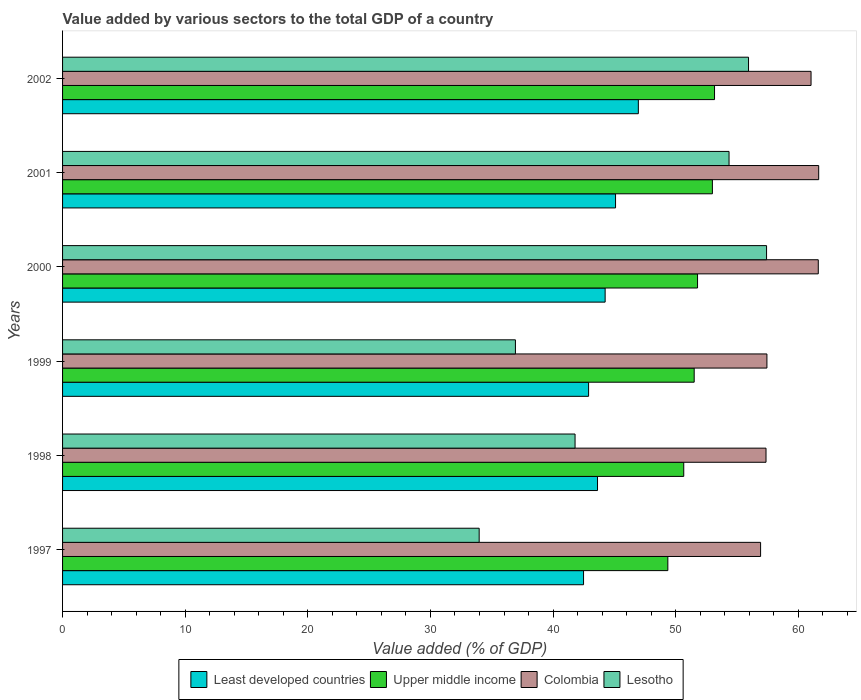How many different coloured bars are there?
Offer a very short reply. 4. Are the number of bars on each tick of the Y-axis equal?
Give a very brief answer. Yes. How many bars are there on the 6th tick from the top?
Give a very brief answer. 4. How many bars are there on the 4th tick from the bottom?
Provide a succinct answer. 4. In how many cases, is the number of bars for a given year not equal to the number of legend labels?
Provide a succinct answer. 0. What is the value added by various sectors to the total GDP in Lesotho in 2002?
Ensure brevity in your answer.  55.94. Across all years, what is the maximum value added by various sectors to the total GDP in Upper middle income?
Provide a short and direct response. 53.17. Across all years, what is the minimum value added by various sectors to the total GDP in Lesotho?
Your answer should be compact. 33.97. In which year was the value added by various sectors to the total GDP in Upper middle income maximum?
Your response must be concise. 2002. In which year was the value added by various sectors to the total GDP in Colombia minimum?
Your response must be concise. 1997. What is the total value added by various sectors to the total GDP in Colombia in the graph?
Ensure brevity in your answer.  356.05. What is the difference between the value added by various sectors to the total GDP in Upper middle income in 2000 and that in 2001?
Keep it short and to the point. -1.21. What is the difference between the value added by various sectors to the total GDP in Least developed countries in 1998 and the value added by various sectors to the total GDP in Upper middle income in 2001?
Your response must be concise. -9.37. What is the average value added by various sectors to the total GDP in Colombia per year?
Your answer should be compact. 59.34. In the year 2002, what is the difference between the value added by various sectors to the total GDP in Upper middle income and value added by various sectors to the total GDP in Least developed countries?
Offer a terse response. 6.21. What is the ratio of the value added by various sectors to the total GDP in Colombia in 1997 to that in 2002?
Your response must be concise. 0.93. Is the value added by various sectors to the total GDP in Colombia in 1998 less than that in 1999?
Ensure brevity in your answer.  Yes. What is the difference between the highest and the second highest value added by various sectors to the total GDP in Least developed countries?
Provide a short and direct response. 1.86. What is the difference between the highest and the lowest value added by various sectors to the total GDP in Colombia?
Your response must be concise. 4.74. Is the sum of the value added by various sectors to the total GDP in Colombia in 1998 and 2001 greater than the maximum value added by various sectors to the total GDP in Upper middle income across all years?
Offer a very short reply. Yes. What does the 1st bar from the top in 2001 represents?
Provide a short and direct response. Lesotho. Is it the case that in every year, the sum of the value added by various sectors to the total GDP in Lesotho and value added by various sectors to the total GDP in Colombia is greater than the value added by various sectors to the total GDP in Least developed countries?
Your answer should be very brief. Yes. Are all the bars in the graph horizontal?
Your answer should be very brief. Yes. What is the difference between two consecutive major ticks on the X-axis?
Keep it short and to the point. 10. Are the values on the major ticks of X-axis written in scientific E-notation?
Your response must be concise. No. Does the graph contain any zero values?
Provide a short and direct response. No. Does the graph contain grids?
Keep it short and to the point. No. Where does the legend appear in the graph?
Provide a short and direct response. Bottom center. How are the legend labels stacked?
Your answer should be very brief. Horizontal. What is the title of the graph?
Offer a terse response. Value added by various sectors to the total GDP of a country. What is the label or title of the X-axis?
Give a very brief answer. Value added (% of GDP). What is the Value added (% of GDP) of Least developed countries in 1997?
Provide a succinct answer. 42.49. What is the Value added (% of GDP) of Upper middle income in 1997?
Provide a short and direct response. 49.36. What is the Value added (% of GDP) in Colombia in 1997?
Give a very brief answer. 56.92. What is the Value added (% of GDP) in Lesotho in 1997?
Give a very brief answer. 33.97. What is the Value added (% of GDP) in Least developed countries in 1998?
Offer a very short reply. 43.62. What is the Value added (% of GDP) in Upper middle income in 1998?
Your response must be concise. 50.66. What is the Value added (% of GDP) in Colombia in 1998?
Make the answer very short. 57.37. What is the Value added (% of GDP) in Lesotho in 1998?
Provide a succinct answer. 41.79. What is the Value added (% of GDP) in Least developed countries in 1999?
Make the answer very short. 42.9. What is the Value added (% of GDP) in Upper middle income in 1999?
Your answer should be compact. 51.51. What is the Value added (% of GDP) of Colombia in 1999?
Your answer should be compact. 57.44. What is the Value added (% of GDP) in Lesotho in 1999?
Your response must be concise. 36.93. What is the Value added (% of GDP) of Least developed countries in 2000?
Make the answer very short. 44.25. What is the Value added (% of GDP) of Upper middle income in 2000?
Ensure brevity in your answer.  51.78. What is the Value added (% of GDP) in Colombia in 2000?
Offer a very short reply. 61.63. What is the Value added (% of GDP) in Lesotho in 2000?
Your answer should be compact. 57.41. What is the Value added (% of GDP) of Least developed countries in 2001?
Your response must be concise. 45.1. What is the Value added (% of GDP) in Upper middle income in 2001?
Offer a very short reply. 52.99. What is the Value added (% of GDP) of Colombia in 2001?
Offer a very short reply. 61.66. What is the Value added (% of GDP) in Lesotho in 2001?
Offer a terse response. 54.35. What is the Value added (% of GDP) in Least developed countries in 2002?
Make the answer very short. 46.95. What is the Value added (% of GDP) in Upper middle income in 2002?
Give a very brief answer. 53.17. What is the Value added (% of GDP) of Colombia in 2002?
Offer a very short reply. 61.04. What is the Value added (% of GDP) in Lesotho in 2002?
Provide a succinct answer. 55.94. Across all years, what is the maximum Value added (% of GDP) of Least developed countries?
Make the answer very short. 46.95. Across all years, what is the maximum Value added (% of GDP) of Upper middle income?
Give a very brief answer. 53.17. Across all years, what is the maximum Value added (% of GDP) of Colombia?
Your answer should be very brief. 61.66. Across all years, what is the maximum Value added (% of GDP) in Lesotho?
Give a very brief answer. 57.41. Across all years, what is the minimum Value added (% of GDP) in Least developed countries?
Provide a succinct answer. 42.49. Across all years, what is the minimum Value added (% of GDP) in Upper middle income?
Offer a very short reply. 49.36. Across all years, what is the minimum Value added (% of GDP) of Colombia?
Ensure brevity in your answer.  56.92. Across all years, what is the minimum Value added (% of GDP) in Lesotho?
Offer a very short reply. 33.97. What is the total Value added (% of GDP) of Least developed countries in the graph?
Your response must be concise. 265.3. What is the total Value added (% of GDP) in Upper middle income in the graph?
Keep it short and to the point. 309.47. What is the total Value added (% of GDP) in Colombia in the graph?
Offer a terse response. 356.05. What is the total Value added (% of GDP) of Lesotho in the graph?
Ensure brevity in your answer.  280.4. What is the difference between the Value added (% of GDP) in Least developed countries in 1997 and that in 1998?
Offer a terse response. -1.14. What is the difference between the Value added (% of GDP) of Upper middle income in 1997 and that in 1998?
Offer a very short reply. -1.3. What is the difference between the Value added (% of GDP) in Colombia in 1997 and that in 1998?
Offer a terse response. -0.44. What is the difference between the Value added (% of GDP) of Lesotho in 1997 and that in 1998?
Keep it short and to the point. -7.82. What is the difference between the Value added (% of GDP) of Least developed countries in 1997 and that in 1999?
Your response must be concise. -0.41. What is the difference between the Value added (% of GDP) of Upper middle income in 1997 and that in 1999?
Provide a succinct answer. -2.15. What is the difference between the Value added (% of GDP) in Colombia in 1997 and that in 1999?
Make the answer very short. -0.52. What is the difference between the Value added (% of GDP) in Lesotho in 1997 and that in 1999?
Ensure brevity in your answer.  -2.96. What is the difference between the Value added (% of GDP) of Least developed countries in 1997 and that in 2000?
Your response must be concise. -1.76. What is the difference between the Value added (% of GDP) in Upper middle income in 1997 and that in 2000?
Offer a very short reply. -2.42. What is the difference between the Value added (% of GDP) of Colombia in 1997 and that in 2000?
Your response must be concise. -4.7. What is the difference between the Value added (% of GDP) of Lesotho in 1997 and that in 2000?
Give a very brief answer. -23.44. What is the difference between the Value added (% of GDP) of Least developed countries in 1997 and that in 2001?
Your response must be concise. -2.61. What is the difference between the Value added (% of GDP) in Upper middle income in 1997 and that in 2001?
Give a very brief answer. -3.63. What is the difference between the Value added (% of GDP) in Colombia in 1997 and that in 2001?
Offer a very short reply. -4.74. What is the difference between the Value added (% of GDP) of Lesotho in 1997 and that in 2001?
Keep it short and to the point. -20.38. What is the difference between the Value added (% of GDP) of Least developed countries in 1997 and that in 2002?
Offer a terse response. -4.47. What is the difference between the Value added (% of GDP) in Upper middle income in 1997 and that in 2002?
Your answer should be compact. -3.81. What is the difference between the Value added (% of GDP) in Colombia in 1997 and that in 2002?
Offer a very short reply. -4.11. What is the difference between the Value added (% of GDP) in Lesotho in 1997 and that in 2002?
Your answer should be very brief. -21.97. What is the difference between the Value added (% of GDP) of Least developed countries in 1998 and that in 1999?
Keep it short and to the point. 0.73. What is the difference between the Value added (% of GDP) of Upper middle income in 1998 and that in 1999?
Provide a short and direct response. -0.85. What is the difference between the Value added (% of GDP) of Colombia in 1998 and that in 1999?
Offer a terse response. -0.07. What is the difference between the Value added (% of GDP) of Lesotho in 1998 and that in 1999?
Keep it short and to the point. 4.86. What is the difference between the Value added (% of GDP) of Least developed countries in 1998 and that in 2000?
Your answer should be very brief. -0.62. What is the difference between the Value added (% of GDP) in Upper middle income in 1998 and that in 2000?
Provide a short and direct response. -1.13. What is the difference between the Value added (% of GDP) of Colombia in 1998 and that in 2000?
Your answer should be compact. -4.26. What is the difference between the Value added (% of GDP) of Lesotho in 1998 and that in 2000?
Provide a succinct answer. -15.62. What is the difference between the Value added (% of GDP) of Least developed countries in 1998 and that in 2001?
Your answer should be compact. -1.47. What is the difference between the Value added (% of GDP) of Upper middle income in 1998 and that in 2001?
Provide a short and direct response. -2.34. What is the difference between the Value added (% of GDP) of Colombia in 1998 and that in 2001?
Your answer should be compact. -4.3. What is the difference between the Value added (% of GDP) in Lesotho in 1998 and that in 2001?
Ensure brevity in your answer.  -12.56. What is the difference between the Value added (% of GDP) in Least developed countries in 1998 and that in 2002?
Your response must be concise. -3.33. What is the difference between the Value added (% of GDP) of Upper middle income in 1998 and that in 2002?
Make the answer very short. -2.51. What is the difference between the Value added (% of GDP) of Colombia in 1998 and that in 2002?
Give a very brief answer. -3.67. What is the difference between the Value added (% of GDP) of Lesotho in 1998 and that in 2002?
Keep it short and to the point. -14.15. What is the difference between the Value added (% of GDP) of Least developed countries in 1999 and that in 2000?
Make the answer very short. -1.35. What is the difference between the Value added (% of GDP) of Upper middle income in 1999 and that in 2000?
Offer a terse response. -0.27. What is the difference between the Value added (% of GDP) of Colombia in 1999 and that in 2000?
Your answer should be compact. -4.19. What is the difference between the Value added (% of GDP) of Lesotho in 1999 and that in 2000?
Make the answer very short. -20.48. What is the difference between the Value added (% of GDP) in Least developed countries in 1999 and that in 2001?
Keep it short and to the point. -2.2. What is the difference between the Value added (% of GDP) of Upper middle income in 1999 and that in 2001?
Provide a short and direct response. -1.48. What is the difference between the Value added (% of GDP) in Colombia in 1999 and that in 2001?
Keep it short and to the point. -4.22. What is the difference between the Value added (% of GDP) of Lesotho in 1999 and that in 2001?
Provide a succinct answer. -17.42. What is the difference between the Value added (% of GDP) of Least developed countries in 1999 and that in 2002?
Keep it short and to the point. -4.06. What is the difference between the Value added (% of GDP) in Upper middle income in 1999 and that in 2002?
Provide a short and direct response. -1.66. What is the difference between the Value added (% of GDP) in Colombia in 1999 and that in 2002?
Your answer should be very brief. -3.6. What is the difference between the Value added (% of GDP) of Lesotho in 1999 and that in 2002?
Your answer should be compact. -19.01. What is the difference between the Value added (% of GDP) of Least developed countries in 2000 and that in 2001?
Make the answer very short. -0.85. What is the difference between the Value added (% of GDP) in Upper middle income in 2000 and that in 2001?
Make the answer very short. -1.21. What is the difference between the Value added (% of GDP) in Colombia in 2000 and that in 2001?
Keep it short and to the point. -0.03. What is the difference between the Value added (% of GDP) in Lesotho in 2000 and that in 2001?
Offer a terse response. 3.06. What is the difference between the Value added (% of GDP) in Least developed countries in 2000 and that in 2002?
Give a very brief answer. -2.71. What is the difference between the Value added (% of GDP) in Upper middle income in 2000 and that in 2002?
Your response must be concise. -1.39. What is the difference between the Value added (% of GDP) in Colombia in 2000 and that in 2002?
Offer a terse response. 0.59. What is the difference between the Value added (% of GDP) in Lesotho in 2000 and that in 2002?
Ensure brevity in your answer.  1.47. What is the difference between the Value added (% of GDP) in Least developed countries in 2001 and that in 2002?
Ensure brevity in your answer.  -1.86. What is the difference between the Value added (% of GDP) in Upper middle income in 2001 and that in 2002?
Make the answer very short. -0.17. What is the difference between the Value added (% of GDP) in Colombia in 2001 and that in 2002?
Make the answer very short. 0.62. What is the difference between the Value added (% of GDP) in Lesotho in 2001 and that in 2002?
Your response must be concise. -1.59. What is the difference between the Value added (% of GDP) of Least developed countries in 1997 and the Value added (% of GDP) of Upper middle income in 1998?
Your answer should be very brief. -8.17. What is the difference between the Value added (% of GDP) in Least developed countries in 1997 and the Value added (% of GDP) in Colombia in 1998?
Offer a terse response. -14.88. What is the difference between the Value added (% of GDP) in Least developed countries in 1997 and the Value added (% of GDP) in Lesotho in 1998?
Your answer should be compact. 0.69. What is the difference between the Value added (% of GDP) in Upper middle income in 1997 and the Value added (% of GDP) in Colombia in 1998?
Offer a very short reply. -8.01. What is the difference between the Value added (% of GDP) in Upper middle income in 1997 and the Value added (% of GDP) in Lesotho in 1998?
Offer a terse response. 7.57. What is the difference between the Value added (% of GDP) of Colombia in 1997 and the Value added (% of GDP) of Lesotho in 1998?
Make the answer very short. 15.13. What is the difference between the Value added (% of GDP) in Least developed countries in 1997 and the Value added (% of GDP) in Upper middle income in 1999?
Your answer should be compact. -9.02. What is the difference between the Value added (% of GDP) in Least developed countries in 1997 and the Value added (% of GDP) in Colombia in 1999?
Your answer should be compact. -14.95. What is the difference between the Value added (% of GDP) of Least developed countries in 1997 and the Value added (% of GDP) of Lesotho in 1999?
Your response must be concise. 5.56. What is the difference between the Value added (% of GDP) in Upper middle income in 1997 and the Value added (% of GDP) in Colombia in 1999?
Your answer should be very brief. -8.08. What is the difference between the Value added (% of GDP) in Upper middle income in 1997 and the Value added (% of GDP) in Lesotho in 1999?
Make the answer very short. 12.43. What is the difference between the Value added (% of GDP) of Colombia in 1997 and the Value added (% of GDP) of Lesotho in 1999?
Provide a succinct answer. 19.99. What is the difference between the Value added (% of GDP) in Least developed countries in 1997 and the Value added (% of GDP) in Upper middle income in 2000?
Offer a very short reply. -9.3. What is the difference between the Value added (% of GDP) of Least developed countries in 1997 and the Value added (% of GDP) of Colombia in 2000?
Your answer should be very brief. -19.14. What is the difference between the Value added (% of GDP) in Least developed countries in 1997 and the Value added (% of GDP) in Lesotho in 2000?
Offer a very short reply. -14.93. What is the difference between the Value added (% of GDP) of Upper middle income in 1997 and the Value added (% of GDP) of Colombia in 2000?
Provide a short and direct response. -12.27. What is the difference between the Value added (% of GDP) of Upper middle income in 1997 and the Value added (% of GDP) of Lesotho in 2000?
Your answer should be very brief. -8.05. What is the difference between the Value added (% of GDP) of Colombia in 1997 and the Value added (% of GDP) of Lesotho in 2000?
Offer a very short reply. -0.49. What is the difference between the Value added (% of GDP) of Least developed countries in 1997 and the Value added (% of GDP) of Upper middle income in 2001?
Keep it short and to the point. -10.51. What is the difference between the Value added (% of GDP) in Least developed countries in 1997 and the Value added (% of GDP) in Colombia in 2001?
Your answer should be very brief. -19.18. What is the difference between the Value added (% of GDP) in Least developed countries in 1997 and the Value added (% of GDP) in Lesotho in 2001?
Ensure brevity in your answer.  -11.86. What is the difference between the Value added (% of GDP) in Upper middle income in 1997 and the Value added (% of GDP) in Colombia in 2001?
Your answer should be compact. -12.3. What is the difference between the Value added (% of GDP) in Upper middle income in 1997 and the Value added (% of GDP) in Lesotho in 2001?
Make the answer very short. -4.99. What is the difference between the Value added (% of GDP) of Colombia in 1997 and the Value added (% of GDP) of Lesotho in 2001?
Offer a very short reply. 2.57. What is the difference between the Value added (% of GDP) in Least developed countries in 1997 and the Value added (% of GDP) in Upper middle income in 2002?
Your answer should be very brief. -10.68. What is the difference between the Value added (% of GDP) in Least developed countries in 1997 and the Value added (% of GDP) in Colombia in 2002?
Make the answer very short. -18.55. What is the difference between the Value added (% of GDP) in Least developed countries in 1997 and the Value added (% of GDP) in Lesotho in 2002?
Your answer should be compact. -13.45. What is the difference between the Value added (% of GDP) in Upper middle income in 1997 and the Value added (% of GDP) in Colombia in 2002?
Your response must be concise. -11.68. What is the difference between the Value added (% of GDP) of Upper middle income in 1997 and the Value added (% of GDP) of Lesotho in 2002?
Offer a very short reply. -6.58. What is the difference between the Value added (% of GDP) of Colombia in 1997 and the Value added (% of GDP) of Lesotho in 2002?
Give a very brief answer. 0.98. What is the difference between the Value added (% of GDP) of Least developed countries in 1998 and the Value added (% of GDP) of Upper middle income in 1999?
Your response must be concise. -7.88. What is the difference between the Value added (% of GDP) of Least developed countries in 1998 and the Value added (% of GDP) of Colombia in 1999?
Your answer should be very brief. -13.82. What is the difference between the Value added (% of GDP) of Least developed countries in 1998 and the Value added (% of GDP) of Lesotho in 1999?
Keep it short and to the point. 6.69. What is the difference between the Value added (% of GDP) in Upper middle income in 1998 and the Value added (% of GDP) in Colombia in 1999?
Offer a very short reply. -6.78. What is the difference between the Value added (% of GDP) in Upper middle income in 1998 and the Value added (% of GDP) in Lesotho in 1999?
Keep it short and to the point. 13.73. What is the difference between the Value added (% of GDP) of Colombia in 1998 and the Value added (% of GDP) of Lesotho in 1999?
Offer a terse response. 20.44. What is the difference between the Value added (% of GDP) in Least developed countries in 1998 and the Value added (% of GDP) in Upper middle income in 2000?
Offer a very short reply. -8.16. What is the difference between the Value added (% of GDP) of Least developed countries in 1998 and the Value added (% of GDP) of Colombia in 2000?
Provide a succinct answer. -18. What is the difference between the Value added (% of GDP) in Least developed countries in 1998 and the Value added (% of GDP) in Lesotho in 2000?
Your answer should be very brief. -13.79. What is the difference between the Value added (% of GDP) in Upper middle income in 1998 and the Value added (% of GDP) in Colombia in 2000?
Make the answer very short. -10.97. What is the difference between the Value added (% of GDP) in Upper middle income in 1998 and the Value added (% of GDP) in Lesotho in 2000?
Offer a terse response. -6.75. What is the difference between the Value added (% of GDP) of Colombia in 1998 and the Value added (% of GDP) of Lesotho in 2000?
Keep it short and to the point. -0.04. What is the difference between the Value added (% of GDP) in Least developed countries in 1998 and the Value added (% of GDP) in Upper middle income in 2001?
Provide a short and direct response. -9.37. What is the difference between the Value added (% of GDP) of Least developed countries in 1998 and the Value added (% of GDP) of Colombia in 2001?
Offer a very short reply. -18.04. What is the difference between the Value added (% of GDP) in Least developed countries in 1998 and the Value added (% of GDP) in Lesotho in 2001?
Offer a very short reply. -10.73. What is the difference between the Value added (% of GDP) of Upper middle income in 1998 and the Value added (% of GDP) of Colombia in 2001?
Your answer should be compact. -11. What is the difference between the Value added (% of GDP) in Upper middle income in 1998 and the Value added (% of GDP) in Lesotho in 2001?
Provide a succinct answer. -3.69. What is the difference between the Value added (% of GDP) in Colombia in 1998 and the Value added (% of GDP) in Lesotho in 2001?
Your response must be concise. 3.02. What is the difference between the Value added (% of GDP) in Least developed countries in 1998 and the Value added (% of GDP) in Upper middle income in 2002?
Your answer should be compact. -9.54. What is the difference between the Value added (% of GDP) of Least developed countries in 1998 and the Value added (% of GDP) of Colombia in 2002?
Give a very brief answer. -17.41. What is the difference between the Value added (% of GDP) in Least developed countries in 1998 and the Value added (% of GDP) in Lesotho in 2002?
Your response must be concise. -12.32. What is the difference between the Value added (% of GDP) of Upper middle income in 1998 and the Value added (% of GDP) of Colombia in 2002?
Provide a succinct answer. -10.38. What is the difference between the Value added (% of GDP) of Upper middle income in 1998 and the Value added (% of GDP) of Lesotho in 2002?
Keep it short and to the point. -5.28. What is the difference between the Value added (% of GDP) of Colombia in 1998 and the Value added (% of GDP) of Lesotho in 2002?
Your response must be concise. 1.43. What is the difference between the Value added (% of GDP) in Least developed countries in 1999 and the Value added (% of GDP) in Upper middle income in 2000?
Provide a succinct answer. -8.89. What is the difference between the Value added (% of GDP) in Least developed countries in 1999 and the Value added (% of GDP) in Colombia in 2000?
Your answer should be compact. -18.73. What is the difference between the Value added (% of GDP) of Least developed countries in 1999 and the Value added (% of GDP) of Lesotho in 2000?
Make the answer very short. -14.51. What is the difference between the Value added (% of GDP) of Upper middle income in 1999 and the Value added (% of GDP) of Colombia in 2000?
Give a very brief answer. -10.12. What is the difference between the Value added (% of GDP) in Upper middle income in 1999 and the Value added (% of GDP) in Lesotho in 2000?
Your answer should be very brief. -5.9. What is the difference between the Value added (% of GDP) in Colombia in 1999 and the Value added (% of GDP) in Lesotho in 2000?
Keep it short and to the point. 0.03. What is the difference between the Value added (% of GDP) of Least developed countries in 1999 and the Value added (% of GDP) of Upper middle income in 2001?
Provide a succinct answer. -10.1. What is the difference between the Value added (% of GDP) in Least developed countries in 1999 and the Value added (% of GDP) in Colombia in 2001?
Offer a terse response. -18.76. What is the difference between the Value added (% of GDP) in Least developed countries in 1999 and the Value added (% of GDP) in Lesotho in 2001?
Provide a succinct answer. -11.45. What is the difference between the Value added (% of GDP) in Upper middle income in 1999 and the Value added (% of GDP) in Colombia in 2001?
Provide a short and direct response. -10.15. What is the difference between the Value added (% of GDP) of Upper middle income in 1999 and the Value added (% of GDP) of Lesotho in 2001?
Your answer should be compact. -2.84. What is the difference between the Value added (% of GDP) in Colombia in 1999 and the Value added (% of GDP) in Lesotho in 2001?
Ensure brevity in your answer.  3.09. What is the difference between the Value added (% of GDP) in Least developed countries in 1999 and the Value added (% of GDP) in Upper middle income in 2002?
Give a very brief answer. -10.27. What is the difference between the Value added (% of GDP) of Least developed countries in 1999 and the Value added (% of GDP) of Colombia in 2002?
Provide a short and direct response. -18.14. What is the difference between the Value added (% of GDP) of Least developed countries in 1999 and the Value added (% of GDP) of Lesotho in 2002?
Your response must be concise. -13.04. What is the difference between the Value added (% of GDP) of Upper middle income in 1999 and the Value added (% of GDP) of Colombia in 2002?
Ensure brevity in your answer.  -9.53. What is the difference between the Value added (% of GDP) of Upper middle income in 1999 and the Value added (% of GDP) of Lesotho in 2002?
Offer a very short reply. -4.43. What is the difference between the Value added (% of GDP) of Colombia in 1999 and the Value added (% of GDP) of Lesotho in 2002?
Give a very brief answer. 1.5. What is the difference between the Value added (% of GDP) of Least developed countries in 2000 and the Value added (% of GDP) of Upper middle income in 2001?
Provide a short and direct response. -8.75. What is the difference between the Value added (% of GDP) in Least developed countries in 2000 and the Value added (% of GDP) in Colombia in 2001?
Offer a very short reply. -17.41. What is the difference between the Value added (% of GDP) in Least developed countries in 2000 and the Value added (% of GDP) in Lesotho in 2001?
Make the answer very short. -10.1. What is the difference between the Value added (% of GDP) in Upper middle income in 2000 and the Value added (% of GDP) in Colombia in 2001?
Provide a short and direct response. -9.88. What is the difference between the Value added (% of GDP) of Upper middle income in 2000 and the Value added (% of GDP) of Lesotho in 2001?
Your answer should be very brief. -2.57. What is the difference between the Value added (% of GDP) of Colombia in 2000 and the Value added (% of GDP) of Lesotho in 2001?
Give a very brief answer. 7.28. What is the difference between the Value added (% of GDP) in Least developed countries in 2000 and the Value added (% of GDP) in Upper middle income in 2002?
Your response must be concise. -8.92. What is the difference between the Value added (% of GDP) in Least developed countries in 2000 and the Value added (% of GDP) in Colombia in 2002?
Offer a very short reply. -16.79. What is the difference between the Value added (% of GDP) of Least developed countries in 2000 and the Value added (% of GDP) of Lesotho in 2002?
Provide a succinct answer. -11.69. What is the difference between the Value added (% of GDP) of Upper middle income in 2000 and the Value added (% of GDP) of Colombia in 2002?
Ensure brevity in your answer.  -9.26. What is the difference between the Value added (% of GDP) in Upper middle income in 2000 and the Value added (% of GDP) in Lesotho in 2002?
Make the answer very short. -4.16. What is the difference between the Value added (% of GDP) of Colombia in 2000 and the Value added (% of GDP) of Lesotho in 2002?
Provide a succinct answer. 5.69. What is the difference between the Value added (% of GDP) in Least developed countries in 2001 and the Value added (% of GDP) in Upper middle income in 2002?
Provide a succinct answer. -8.07. What is the difference between the Value added (% of GDP) in Least developed countries in 2001 and the Value added (% of GDP) in Colombia in 2002?
Offer a very short reply. -15.94. What is the difference between the Value added (% of GDP) of Least developed countries in 2001 and the Value added (% of GDP) of Lesotho in 2002?
Your response must be concise. -10.84. What is the difference between the Value added (% of GDP) of Upper middle income in 2001 and the Value added (% of GDP) of Colombia in 2002?
Keep it short and to the point. -8.05. What is the difference between the Value added (% of GDP) of Upper middle income in 2001 and the Value added (% of GDP) of Lesotho in 2002?
Offer a very short reply. -2.95. What is the difference between the Value added (% of GDP) of Colombia in 2001 and the Value added (% of GDP) of Lesotho in 2002?
Your response must be concise. 5.72. What is the average Value added (% of GDP) of Least developed countries per year?
Ensure brevity in your answer.  44.22. What is the average Value added (% of GDP) of Upper middle income per year?
Make the answer very short. 51.58. What is the average Value added (% of GDP) in Colombia per year?
Keep it short and to the point. 59.34. What is the average Value added (% of GDP) of Lesotho per year?
Your answer should be very brief. 46.73. In the year 1997, what is the difference between the Value added (% of GDP) in Least developed countries and Value added (% of GDP) in Upper middle income?
Make the answer very short. -6.87. In the year 1997, what is the difference between the Value added (% of GDP) in Least developed countries and Value added (% of GDP) in Colombia?
Provide a short and direct response. -14.44. In the year 1997, what is the difference between the Value added (% of GDP) in Least developed countries and Value added (% of GDP) in Lesotho?
Your answer should be compact. 8.51. In the year 1997, what is the difference between the Value added (% of GDP) in Upper middle income and Value added (% of GDP) in Colombia?
Provide a short and direct response. -7.56. In the year 1997, what is the difference between the Value added (% of GDP) in Upper middle income and Value added (% of GDP) in Lesotho?
Your response must be concise. 15.39. In the year 1997, what is the difference between the Value added (% of GDP) in Colombia and Value added (% of GDP) in Lesotho?
Your response must be concise. 22.95. In the year 1998, what is the difference between the Value added (% of GDP) of Least developed countries and Value added (% of GDP) of Upper middle income?
Your answer should be very brief. -7.03. In the year 1998, what is the difference between the Value added (% of GDP) of Least developed countries and Value added (% of GDP) of Colombia?
Keep it short and to the point. -13.74. In the year 1998, what is the difference between the Value added (% of GDP) of Least developed countries and Value added (% of GDP) of Lesotho?
Your answer should be compact. 1.83. In the year 1998, what is the difference between the Value added (% of GDP) in Upper middle income and Value added (% of GDP) in Colombia?
Offer a terse response. -6.71. In the year 1998, what is the difference between the Value added (% of GDP) of Upper middle income and Value added (% of GDP) of Lesotho?
Your response must be concise. 8.86. In the year 1998, what is the difference between the Value added (% of GDP) of Colombia and Value added (% of GDP) of Lesotho?
Keep it short and to the point. 15.57. In the year 1999, what is the difference between the Value added (% of GDP) in Least developed countries and Value added (% of GDP) in Upper middle income?
Your answer should be compact. -8.61. In the year 1999, what is the difference between the Value added (% of GDP) in Least developed countries and Value added (% of GDP) in Colombia?
Give a very brief answer. -14.54. In the year 1999, what is the difference between the Value added (% of GDP) of Least developed countries and Value added (% of GDP) of Lesotho?
Your answer should be compact. 5.97. In the year 1999, what is the difference between the Value added (% of GDP) of Upper middle income and Value added (% of GDP) of Colombia?
Your response must be concise. -5.93. In the year 1999, what is the difference between the Value added (% of GDP) in Upper middle income and Value added (% of GDP) in Lesotho?
Ensure brevity in your answer.  14.58. In the year 1999, what is the difference between the Value added (% of GDP) of Colombia and Value added (% of GDP) of Lesotho?
Offer a terse response. 20.51. In the year 2000, what is the difference between the Value added (% of GDP) in Least developed countries and Value added (% of GDP) in Upper middle income?
Your answer should be compact. -7.54. In the year 2000, what is the difference between the Value added (% of GDP) in Least developed countries and Value added (% of GDP) in Colombia?
Keep it short and to the point. -17.38. In the year 2000, what is the difference between the Value added (% of GDP) in Least developed countries and Value added (% of GDP) in Lesotho?
Your response must be concise. -13.16. In the year 2000, what is the difference between the Value added (% of GDP) in Upper middle income and Value added (% of GDP) in Colombia?
Your response must be concise. -9.85. In the year 2000, what is the difference between the Value added (% of GDP) in Upper middle income and Value added (% of GDP) in Lesotho?
Offer a terse response. -5.63. In the year 2000, what is the difference between the Value added (% of GDP) of Colombia and Value added (% of GDP) of Lesotho?
Provide a succinct answer. 4.22. In the year 2001, what is the difference between the Value added (% of GDP) of Least developed countries and Value added (% of GDP) of Upper middle income?
Offer a terse response. -7.9. In the year 2001, what is the difference between the Value added (% of GDP) in Least developed countries and Value added (% of GDP) in Colombia?
Your response must be concise. -16.57. In the year 2001, what is the difference between the Value added (% of GDP) of Least developed countries and Value added (% of GDP) of Lesotho?
Your answer should be compact. -9.25. In the year 2001, what is the difference between the Value added (% of GDP) in Upper middle income and Value added (% of GDP) in Colombia?
Your answer should be compact. -8.67. In the year 2001, what is the difference between the Value added (% of GDP) of Upper middle income and Value added (% of GDP) of Lesotho?
Offer a very short reply. -1.36. In the year 2001, what is the difference between the Value added (% of GDP) of Colombia and Value added (% of GDP) of Lesotho?
Offer a very short reply. 7.31. In the year 2002, what is the difference between the Value added (% of GDP) in Least developed countries and Value added (% of GDP) in Upper middle income?
Your answer should be very brief. -6.21. In the year 2002, what is the difference between the Value added (% of GDP) in Least developed countries and Value added (% of GDP) in Colombia?
Ensure brevity in your answer.  -14.08. In the year 2002, what is the difference between the Value added (% of GDP) in Least developed countries and Value added (% of GDP) in Lesotho?
Give a very brief answer. -8.99. In the year 2002, what is the difference between the Value added (% of GDP) of Upper middle income and Value added (% of GDP) of Colombia?
Your answer should be very brief. -7.87. In the year 2002, what is the difference between the Value added (% of GDP) of Upper middle income and Value added (% of GDP) of Lesotho?
Your response must be concise. -2.77. In the year 2002, what is the difference between the Value added (% of GDP) in Colombia and Value added (% of GDP) in Lesotho?
Offer a very short reply. 5.1. What is the ratio of the Value added (% of GDP) in Least developed countries in 1997 to that in 1998?
Offer a terse response. 0.97. What is the ratio of the Value added (% of GDP) in Upper middle income in 1997 to that in 1998?
Offer a very short reply. 0.97. What is the ratio of the Value added (% of GDP) of Colombia in 1997 to that in 1998?
Your answer should be compact. 0.99. What is the ratio of the Value added (% of GDP) in Lesotho in 1997 to that in 1998?
Keep it short and to the point. 0.81. What is the ratio of the Value added (% of GDP) in Colombia in 1997 to that in 1999?
Offer a very short reply. 0.99. What is the ratio of the Value added (% of GDP) in Lesotho in 1997 to that in 1999?
Provide a succinct answer. 0.92. What is the ratio of the Value added (% of GDP) in Least developed countries in 1997 to that in 2000?
Your answer should be very brief. 0.96. What is the ratio of the Value added (% of GDP) in Upper middle income in 1997 to that in 2000?
Your answer should be very brief. 0.95. What is the ratio of the Value added (% of GDP) in Colombia in 1997 to that in 2000?
Make the answer very short. 0.92. What is the ratio of the Value added (% of GDP) in Lesotho in 1997 to that in 2000?
Ensure brevity in your answer.  0.59. What is the ratio of the Value added (% of GDP) in Least developed countries in 1997 to that in 2001?
Your answer should be compact. 0.94. What is the ratio of the Value added (% of GDP) in Upper middle income in 1997 to that in 2001?
Make the answer very short. 0.93. What is the ratio of the Value added (% of GDP) in Colombia in 1997 to that in 2001?
Provide a short and direct response. 0.92. What is the ratio of the Value added (% of GDP) of Lesotho in 1997 to that in 2001?
Make the answer very short. 0.63. What is the ratio of the Value added (% of GDP) in Least developed countries in 1997 to that in 2002?
Ensure brevity in your answer.  0.9. What is the ratio of the Value added (% of GDP) in Upper middle income in 1997 to that in 2002?
Your response must be concise. 0.93. What is the ratio of the Value added (% of GDP) of Colombia in 1997 to that in 2002?
Ensure brevity in your answer.  0.93. What is the ratio of the Value added (% of GDP) in Lesotho in 1997 to that in 2002?
Your answer should be compact. 0.61. What is the ratio of the Value added (% of GDP) of Least developed countries in 1998 to that in 1999?
Keep it short and to the point. 1.02. What is the ratio of the Value added (% of GDP) in Upper middle income in 1998 to that in 1999?
Make the answer very short. 0.98. What is the ratio of the Value added (% of GDP) of Colombia in 1998 to that in 1999?
Your answer should be compact. 1. What is the ratio of the Value added (% of GDP) of Lesotho in 1998 to that in 1999?
Keep it short and to the point. 1.13. What is the ratio of the Value added (% of GDP) in Least developed countries in 1998 to that in 2000?
Provide a short and direct response. 0.99. What is the ratio of the Value added (% of GDP) of Upper middle income in 1998 to that in 2000?
Your response must be concise. 0.98. What is the ratio of the Value added (% of GDP) of Colombia in 1998 to that in 2000?
Keep it short and to the point. 0.93. What is the ratio of the Value added (% of GDP) in Lesotho in 1998 to that in 2000?
Make the answer very short. 0.73. What is the ratio of the Value added (% of GDP) in Least developed countries in 1998 to that in 2001?
Ensure brevity in your answer.  0.97. What is the ratio of the Value added (% of GDP) in Upper middle income in 1998 to that in 2001?
Keep it short and to the point. 0.96. What is the ratio of the Value added (% of GDP) of Colombia in 1998 to that in 2001?
Your answer should be very brief. 0.93. What is the ratio of the Value added (% of GDP) in Lesotho in 1998 to that in 2001?
Provide a short and direct response. 0.77. What is the ratio of the Value added (% of GDP) of Least developed countries in 1998 to that in 2002?
Give a very brief answer. 0.93. What is the ratio of the Value added (% of GDP) of Upper middle income in 1998 to that in 2002?
Provide a succinct answer. 0.95. What is the ratio of the Value added (% of GDP) in Colombia in 1998 to that in 2002?
Keep it short and to the point. 0.94. What is the ratio of the Value added (% of GDP) in Lesotho in 1998 to that in 2002?
Give a very brief answer. 0.75. What is the ratio of the Value added (% of GDP) of Least developed countries in 1999 to that in 2000?
Your answer should be compact. 0.97. What is the ratio of the Value added (% of GDP) of Upper middle income in 1999 to that in 2000?
Give a very brief answer. 0.99. What is the ratio of the Value added (% of GDP) of Colombia in 1999 to that in 2000?
Your answer should be very brief. 0.93. What is the ratio of the Value added (% of GDP) of Lesotho in 1999 to that in 2000?
Offer a terse response. 0.64. What is the ratio of the Value added (% of GDP) in Least developed countries in 1999 to that in 2001?
Provide a succinct answer. 0.95. What is the ratio of the Value added (% of GDP) in Colombia in 1999 to that in 2001?
Ensure brevity in your answer.  0.93. What is the ratio of the Value added (% of GDP) of Lesotho in 1999 to that in 2001?
Provide a short and direct response. 0.68. What is the ratio of the Value added (% of GDP) of Least developed countries in 1999 to that in 2002?
Make the answer very short. 0.91. What is the ratio of the Value added (% of GDP) of Upper middle income in 1999 to that in 2002?
Ensure brevity in your answer.  0.97. What is the ratio of the Value added (% of GDP) of Colombia in 1999 to that in 2002?
Your answer should be very brief. 0.94. What is the ratio of the Value added (% of GDP) of Lesotho in 1999 to that in 2002?
Ensure brevity in your answer.  0.66. What is the ratio of the Value added (% of GDP) of Least developed countries in 2000 to that in 2001?
Offer a terse response. 0.98. What is the ratio of the Value added (% of GDP) of Upper middle income in 2000 to that in 2001?
Keep it short and to the point. 0.98. What is the ratio of the Value added (% of GDP) in Colombia in 2000 to that in 2001?
Give a very brief answer. 1. What is the ratio of the Value added (% of GDP) of Lesotho in 2000 to that in 2001?
Your response must be concise. 1.06. What is the ratio of the Value added (% of GDP) in Least developed countries in 2000 to that in 2002?
Offer a terse response. 0.94. What is the ratio of the Value added (% of GDP) in Upper middle income in 2000 to that in 2002?
Your answer should be very brief. 0.97. What is the ratio of the Value added (% of GDP) of Colombia in 2000 to that in 2002?
Give a very brief answer. 1.01. What is the ratio of the Value added (% of GDP) in Lesotho in 2000 to that in 2002?
Keep it short and to the point. 1.03. What is the ratio of the Value added (% of GDP) of Least developed countries in 2001 to that in 2002?
Your response must be concise. 0.96. What is the ratio of the Value added (% of GDP) of Upper middle income in 2001 to that in 2002?
Provide a succinct answer. 1. What is the ratio of the Value added (% of GDP) in Colombia in 2001 to that in 2002?
Your answer should be very brief. 1.01. What is the ratio of the Value added (% of GDP) of Lesotho in 2001 to that in 2002?
Make the answer very short. 0.97. What is the difference between the highest and the second highest Value added (% of GDP) of Least developed countries?
Provide a short and direct response. 1.86. What is the difference between the highest and the second highest Value added (% of GDP) of Upper middle income?
Give a very brief answer. 0.17. What is the difference between the highest and the second highest Value added (% of GDP) in Colombia?
Ensure brevity in your answer.  0.03. What is the difference between the highest and the second highest Value added (% of GDP) of Lesotho?
Make the answer very short. 1.47. What is the difference between the highest and the lowest Value added (% of GDP) in Least developed countries?
Your answer should be very brief. 4.47. What is the difference between the highest and the lowest Value added (% of GDP) in Upper middle income?
Provide a succinct answer. 3.81. What is the difference between the highest and the lowest Value added (% of GDP) in Colombia?
Offer a terse response. 4.74. What is the difference between the highest and the lowest Value added (% of GDP) of Lesotho?
Your answer should be compact. 23.44. 